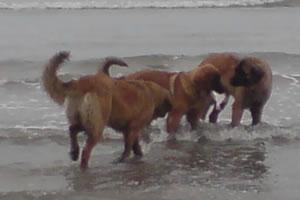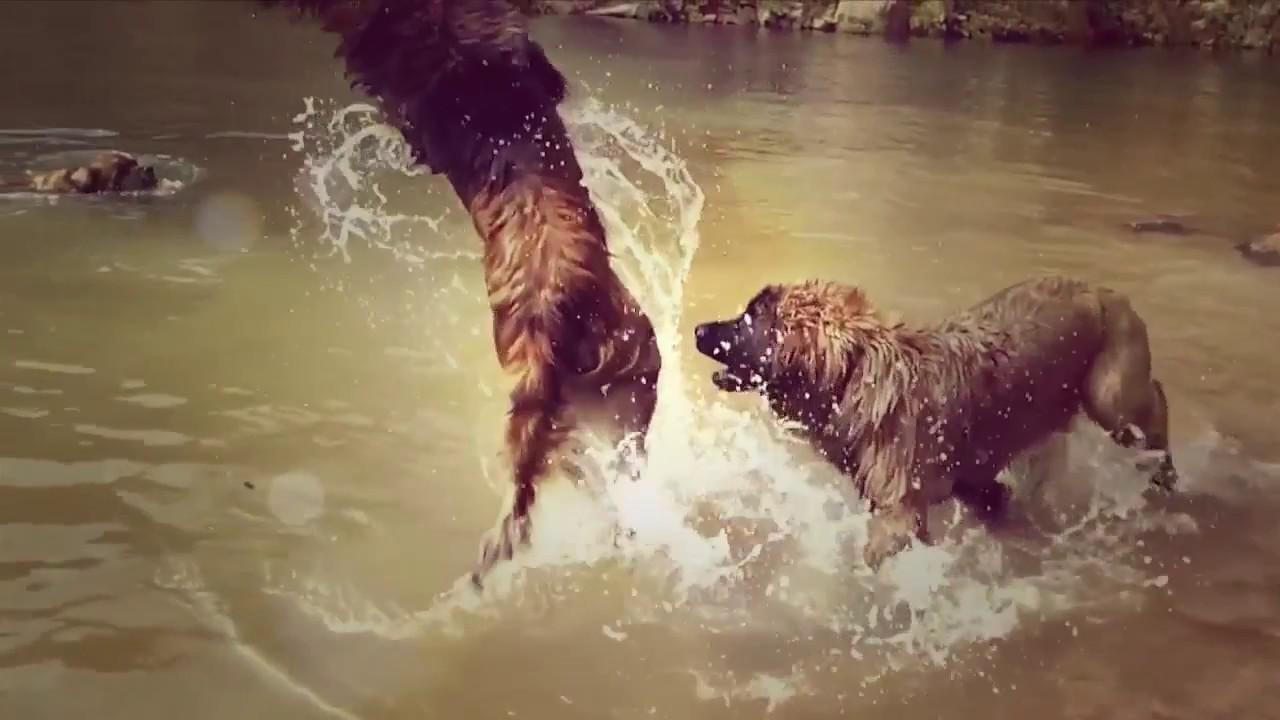The first image is the image on the left, the second image is the image on the right. For the images displayed, is the sentence "A person stands face-to-face with arms around a big standing dog." factually correct? Answer yes or no. No. The first image is the image on the left, the second image is the image on the right. For the images shown, is this caption "A dog is hugging a human in one of the images." true? Answer yes or no. No. 